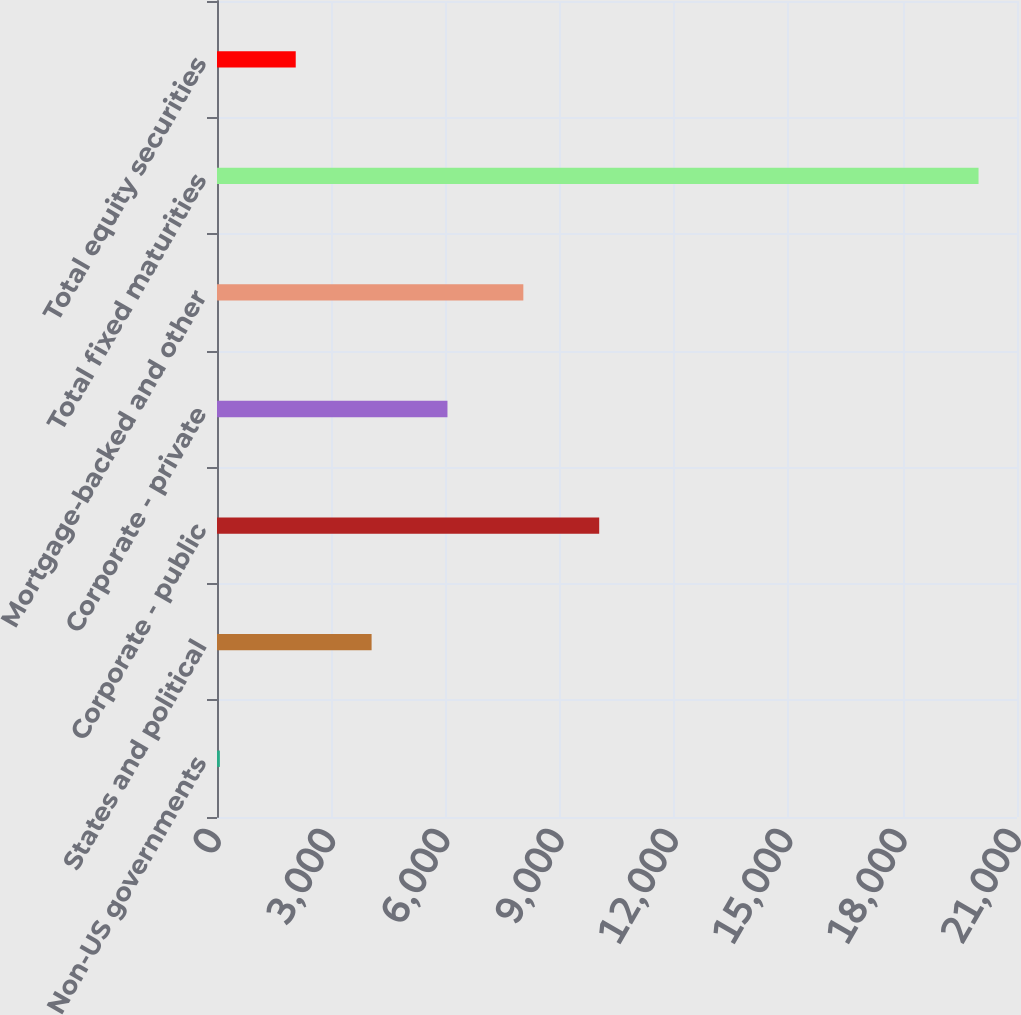Convert chart. <chart><loc_0><loc_0><loc_500><loc_500><bar_chart><fcel>Non-US governments<fcel>States and political<fcel>Corporate - public<fcel>Corporate - private<fcel>Mortgage-backed and other<fcel>Total fixed maturities<fcel>Total equity securities<nl><fcel>75.1<fcel>4058.16<fcel>10032.8<fcel>6049.69<fcel>8041.22<fcel>19990.4<fcel>2066.63<nl></chart> 